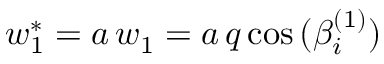Convert formula to latex. <formula><loc_0><loc_0><loc_500><loc_500>w _ { 1 } ^ { * } = a \, w _ { 1 } = a \, q \cos { ( \beta _ { i } ^ { ( 1 ) } ) }</formula> 